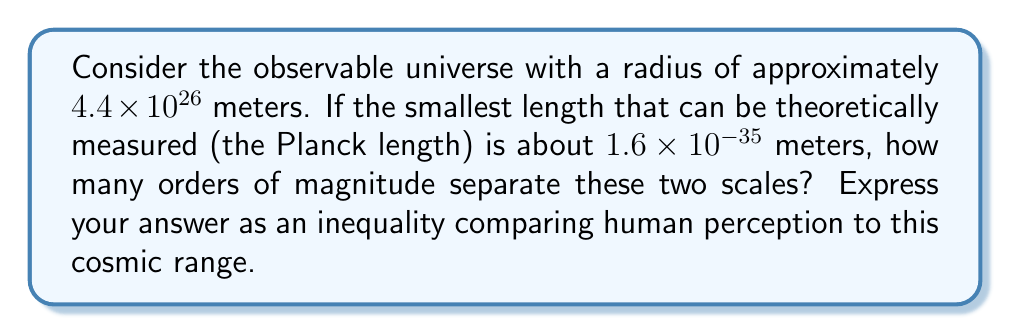Give your solution to this math problem. To solve this problem, we need to follow these steps:

1) First, let's calculate the ratio between the radius of the observable universe and the Planck length:

   $$\frac{4.4 \times 10^{26}}{1.6 \times 10^{-35}} = 2.75 \times 10^{61}$$

2) To find the number of orders of magnitude, we need to take the logarithm (base 10) of this ratio:

   $$\log_{10}(2.75 \times 10^{61}) \approx 61.44$$

3) This means there are about 61 orders of magnitude between these two scales.

4) Now, let's consider human perception. The human eye can typically resolve objects about 0.1 mm (or $10^{-4}$ m) in size.

5) Comparing this to the Planck length:

   $$\frac{10^{-4}}{1.6 \times 10^{-35}} \approx 6.25 \times 10^{30}$$

6) Taking the logarithm:

   $$\log_{10}(6.25 \times 10^{30}) \approx 30.80$$

7) This means human visual perception spans about 31 orders of magnitude above the Planck length.

8) Therefore, human perception covers less than half of the total range between the Planck length and the observable universe.

9) We can express this as an inequality:

   Human perceptual range $< \frac{1}{2}$ (Total cosmic range)
Answer: Human perceptual range $< \frac{1}{2}$ (Total cosmic range) 